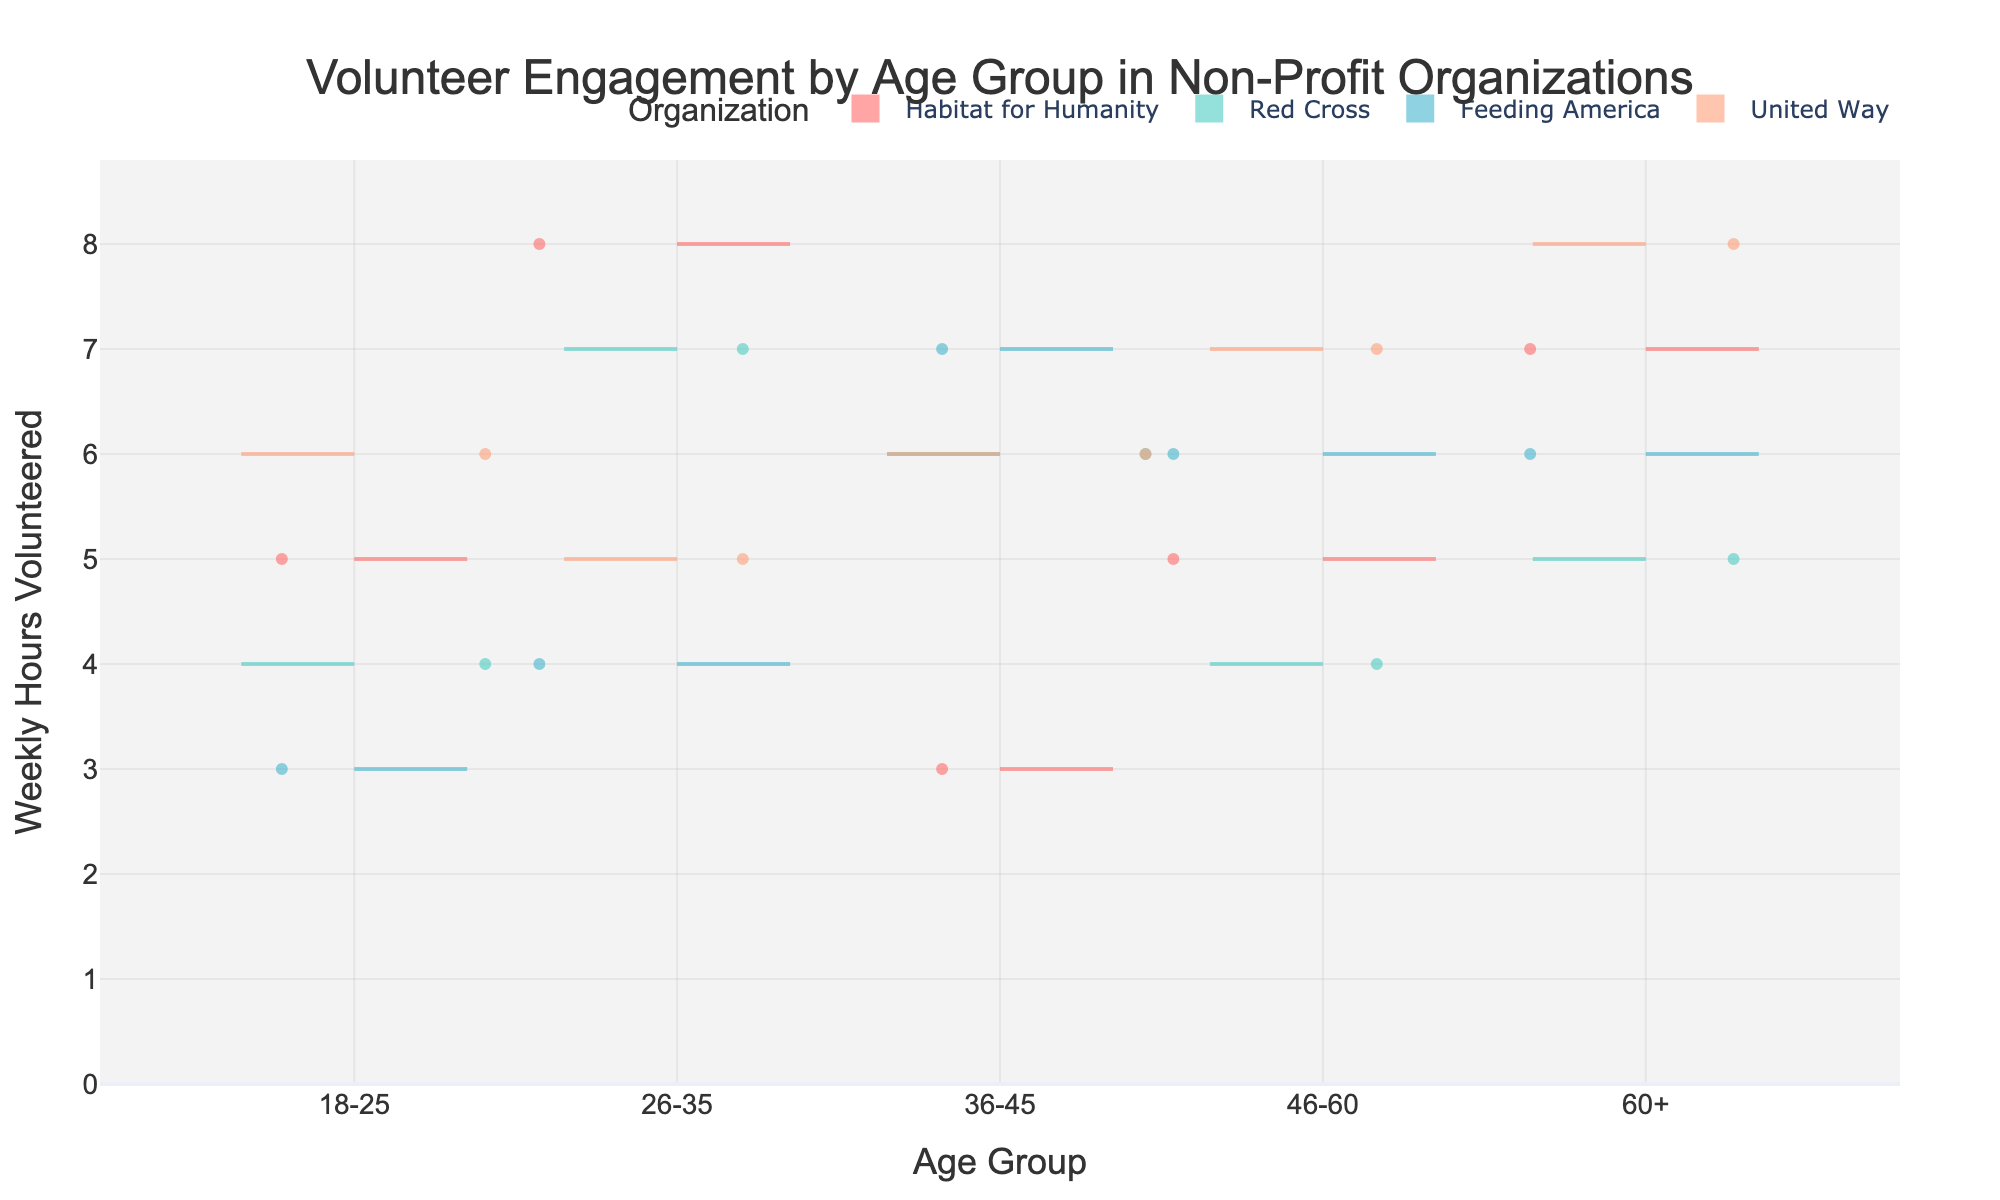What's the title of the figure? The title is prominently displayed at the top of the figure to give viewers an immediate understanding of the subject matter. Here, the title reads "Volunteer Engagement by Age Group in Non-Profit Organizations".
Answer: Volunteer Engagement by Age Group in Non-Profit Organizations What does the x-axis represent? The x-axis contains labels indicating the different age groups of volunteers. It helps to categorize the data by age. The specific age groups are "18-25," "26-35," "36-45," "46-60," and "60+".
Answer: Age Group What is the maximum number of weekly hours volunteered in the 26-35 age group for Habitat for Humanity? By observing the section of the violin plot corresponding to the 26-35 age group and looking for the highest point on the distribution for Habitat for Humanity (represented by the first color), you can identify the maximum value. The highest point reaches 8 hours.
Answer: 8 Among the organizations, which one shows a symmetrical distribution of volunteered hours in the 36-45 age group? A symmetrical distribution would appear as a balanced and even distribution on both sides of the violin plot. For the 36-45 age group, United Way shows this kind of symmetry.
Answer: United Way Which age group has the highest average weekly hours volunteered across all organizations? To determine the highest average, you need to visually estimate the spread and central tendency of each violin plot for each age group and compare them. The 60+ age group shows violin plots distributed with higher average weekly hours.
Answer: 60+ How does the variability in weekly hours volunteered compare between the age groups 18-25 and 46-60 for the Red Cross? Variability can be assessed by the width and spread of the violin plot. For the Red Cross, the 46-60 age group has less spread and tighter clustering compared to the wider and more varied spread of the 18-25 age group.
Answer: 46-60 has less variability What is the range of weekly hours volunteered for Feeding America in the 36-45 age group? The range can be observed by identifying the lowest and highest points in the violin plot for Feeding America in the 36-45 age group. The lowest value is 7, and the highest value is 7, leading to a range of 0.
Answer: 0 Which age group shows the most variation in weekly volunteer hours for United Way? By observing the width and spread of the United Way's violin plots across different age groups, the 60+ age group displays the most variation as it has the widest distribution.
Answer: 60+ Is there a notable trend in volunteer engagement as age increases for Habitat for Humanity? By examining the shapes and positions of the violin plots for each age group corresponding to Habitat for Humanity, a visual trend of increasing average volunteer hours with age can be observed.
Answer: Increasing with age Which organization has the least weekly hours volunteered on average across all age groups? To determine this, visually compare the central tendencies (means) across age groups in each of the organizations. Feeding America tends to have the lowest average weekly hours volunteered across all age groups.
Answer: Feeding America 